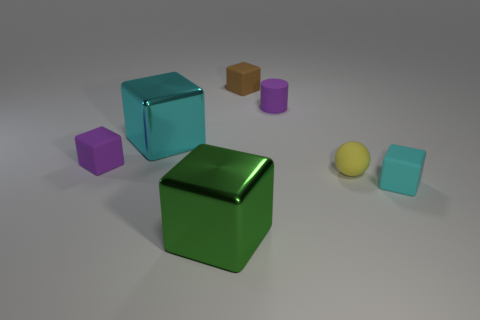Subtract all matte blocks. How many blocks are left? 2 Subtract 3 blocks. How many blocks are left? 2 Subtract all gray balls. How many cyan blocks are left? 2 Subtract all cyan cubes. How many cubes are left? 3 Add 1 green metallic cylinders. How many objects exist? 8 Subtract all brown cubes. Subtract all brown spheres. How many cubes are left? 4 Subtract 1 green blocks. How many objects are left? 6 Subtract all spheres. How many objects are left? 6 Subtract all big blocks. Subtract all green objects. How many objects are left? 4 Add 2 tiny purple things. How many tiny purple things are left? 4 